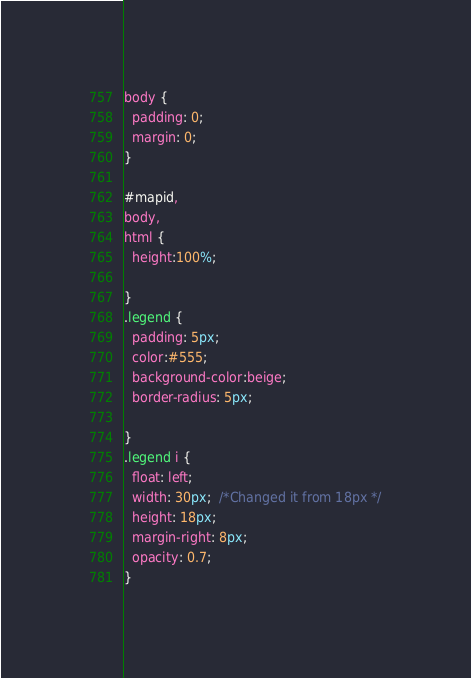Convert code to text. <code><loc_0><loc_0><loc_500><loc_500><_CSS_>body {
  padding: 0;
  margin: 0;
}

#mapid,
body,
html {
  height:100%;
  
}
.legend {
  padding: 5px;
  color:#555;
  background-color:beige;
  border-radius: 5px;
 
}
.legend i {
  float: left;
  width: 30px;  /*Changed it from 18px */
  height: 18px;
  margin-right: 8px;
  opacity: 0.7;
}</code> 